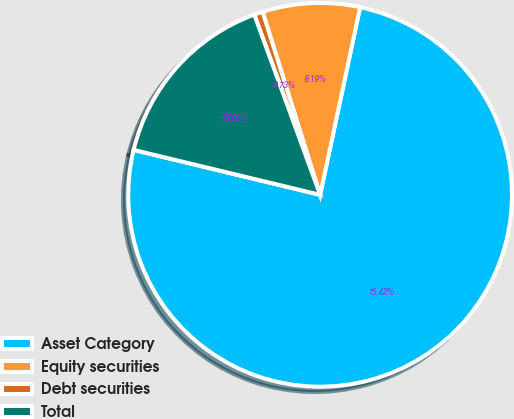Convert chart. <chart><loc_0><loc_0><loc_500><loc_500><pie_chart><fcel>Asset Category<fcel>Equity securities<fcel>Debt securities<fcel>Total<nl><fcel>75.42%<fcel>8.19%<fcel>0.73%<fcel>15.66%<nl></chart> 